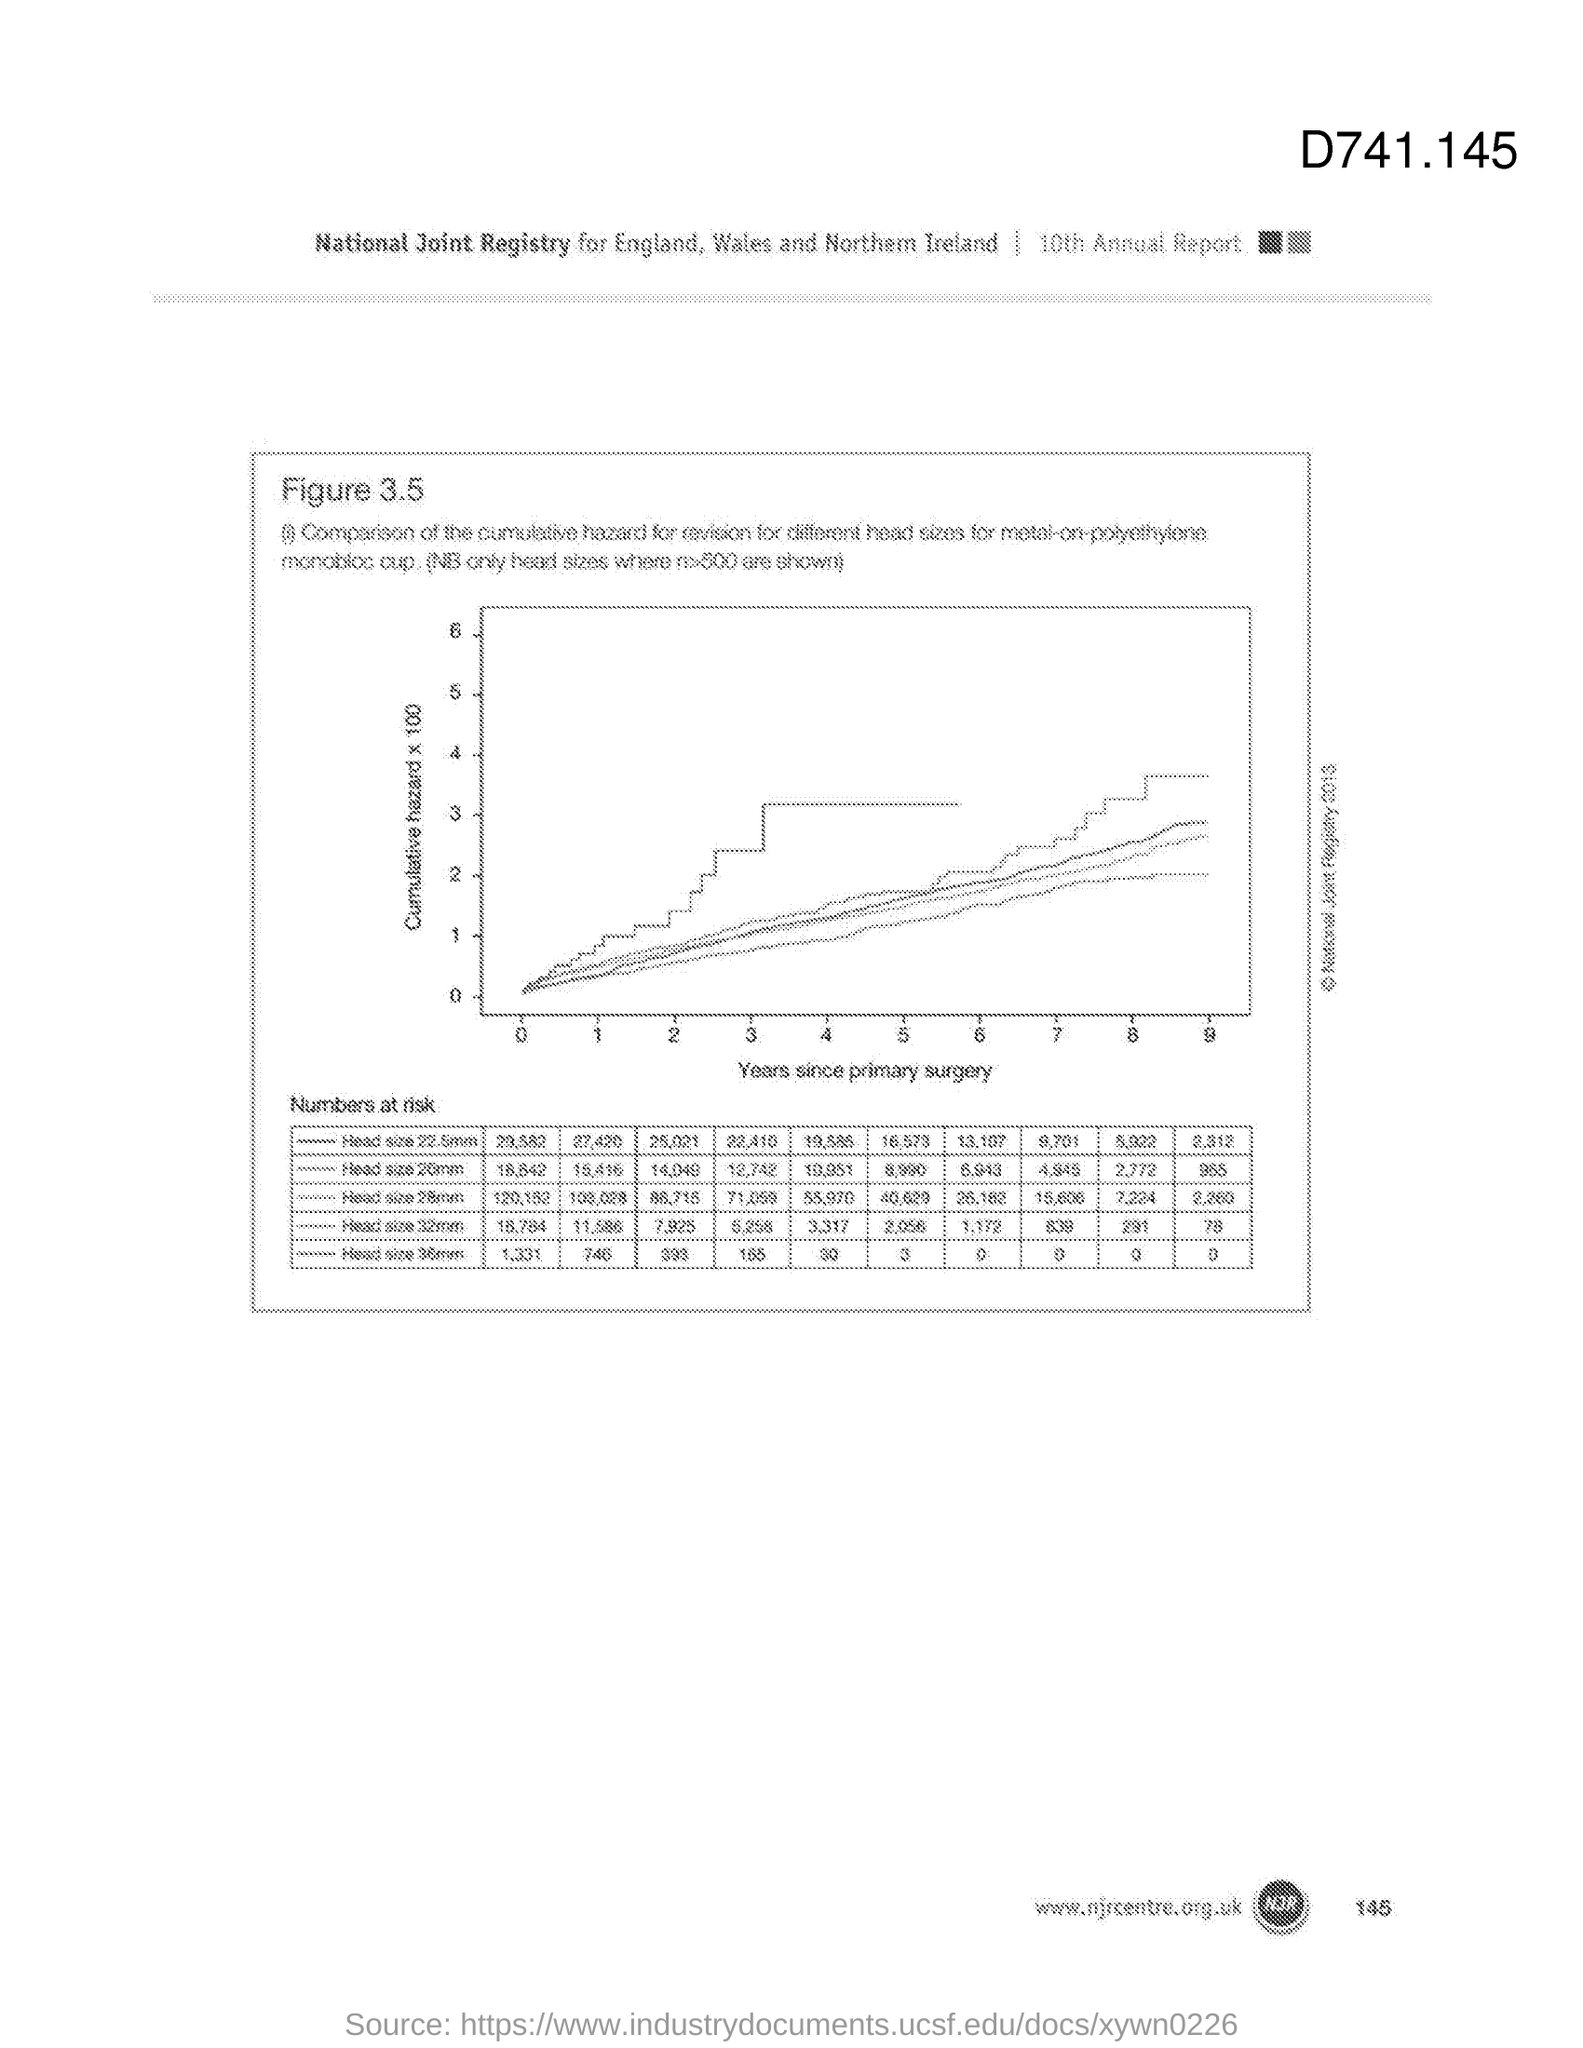Highlight a few significant elements in this photo. The variable on the y-axis of the graph is the cumulative hazard, which has been multiplied by 100. The variable on the X-axis of the graph is the number of years since the patient's primary surgery. 